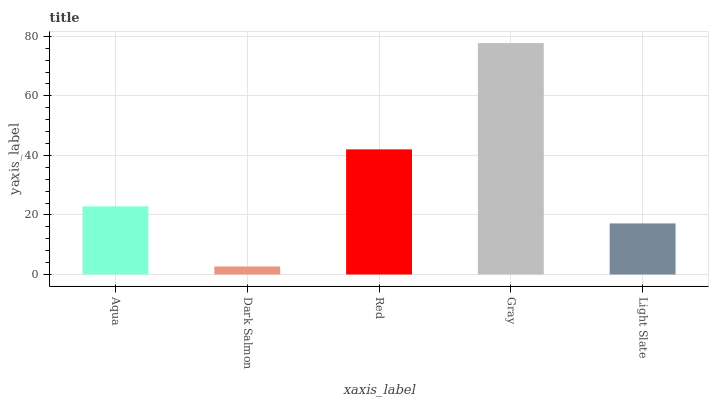Is Dark Salmon the minimum?
Answer yes or no. Yes. Is Gray the maximum?
Answer yes or no. Yes. Is Red the minimum?
Answer yes or no. No. Is Red the maximum?
Answer yes or no. No. Is Red greater than Dark Salmon?
Answer yes or no. Yes. Is Dark Salmon less than Red?
Answer yes or no. Yes. Is Dark Salmon greater than Red?
Answer yes or no. No. Is Red less than Dark Salmon?
Answer yes or no. No. Is Aqua the high median?
Answer yes or no. Yes. Is Aqua the low median?
Answer yes or no. Yes. Is Gray the high median?
Answer yes or no. No. Is Light Slate the low median?
Answer yes or no. No. 